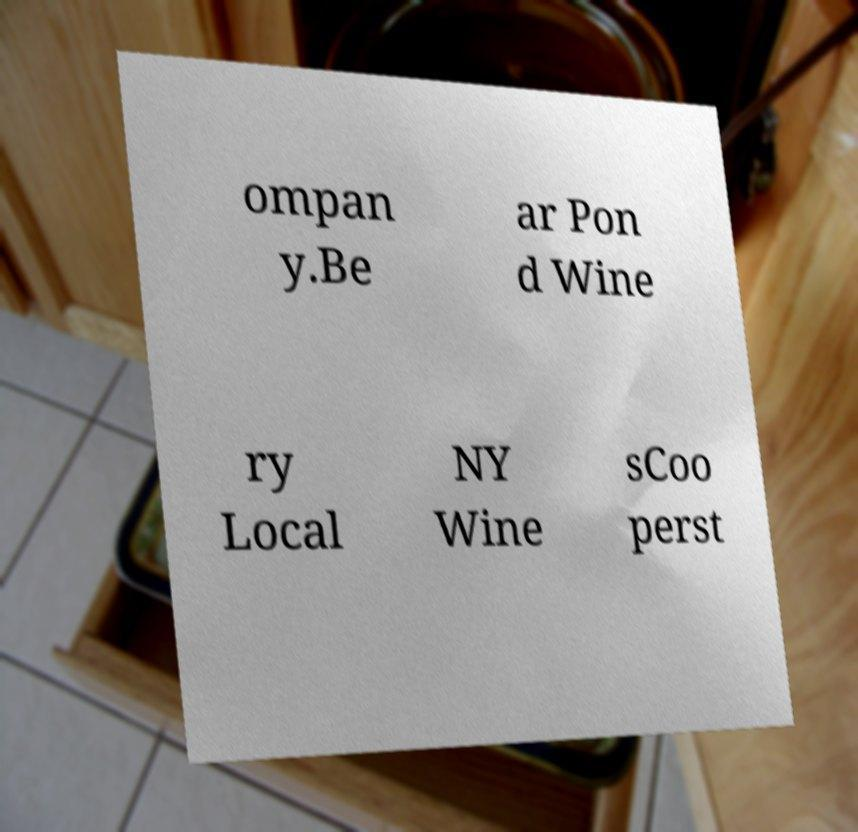I need the written content from this picture converted into text. Can you do that? ompan y.Be ar Pon d Wine ry Local NY Wine sCoo perst 